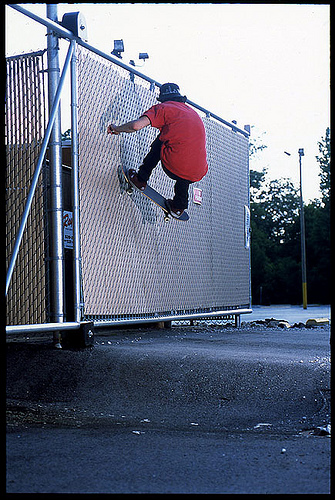<image>What trick is this? I am not sure about the exact trick. It could be a fence ride, up wallie, wallride, ollie or just a jump. What trick is this? I am not sure what trick this is. It can be fence ride, up wallie, skateboard, jump, wallride or ollie. 